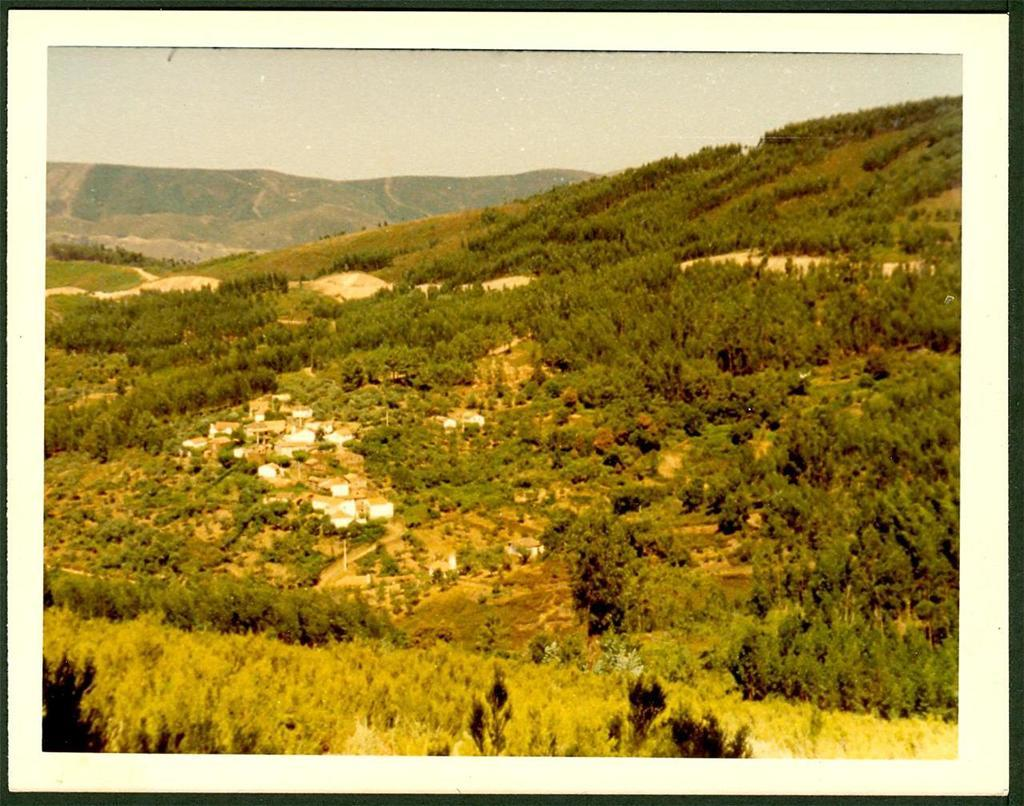What can be seen in the middle of the image? There are trees and houses in the middle of the image. What type of natural features are visible in the background of the image? There are hills visible in the background of the image. What is visible at the top of the image? The sky is visible at the top of the image. What does the stomach of the tree in the image smell like? There is no mention of a tree's stomach or any smells in the image, as trees do not have stomachs. 